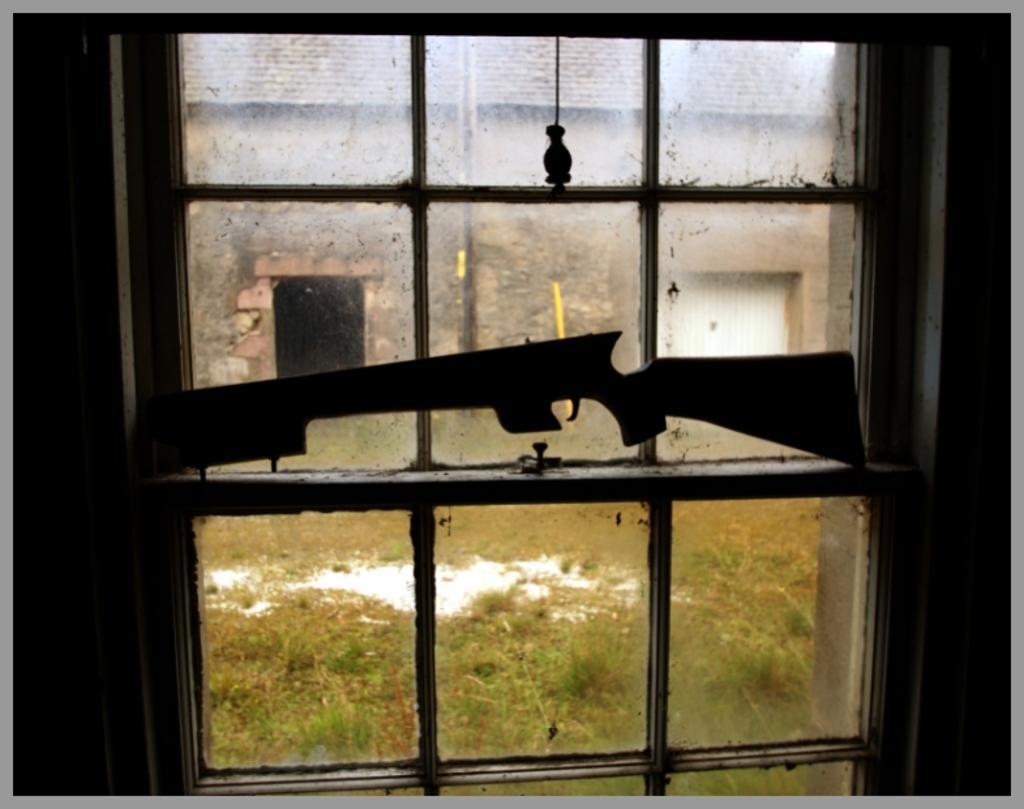How would you summarize this image in a sentence or two? This picture is an edited picture. In this image there is a gun on the window. There is a building behind the window. At the bottom there is grass. 